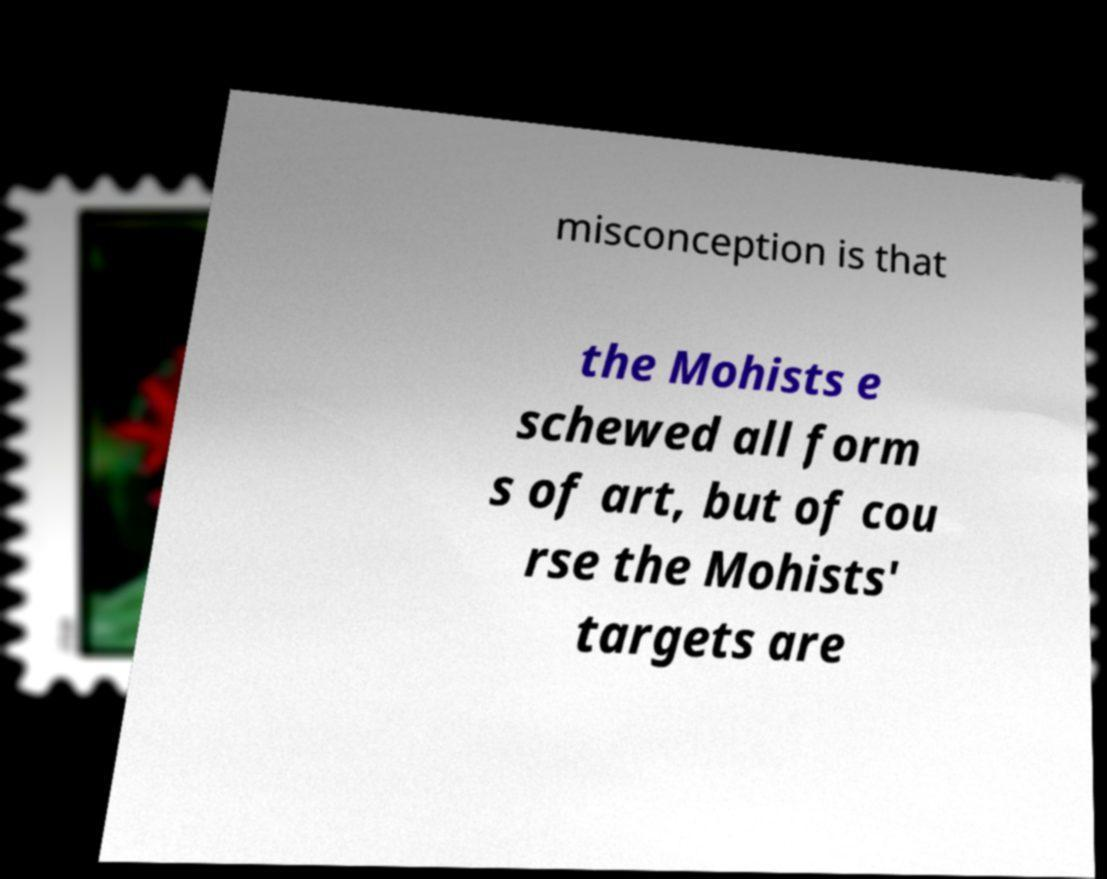Could you assist in decoding the text presented in this image and type it out clearly? misconception is that the Mohists e schewed all form s of art, but of cou rse the Mohists' targets are 